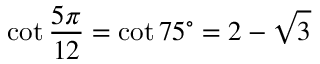Convert formula to latex. <formula><loc_0><loc_0><loc_500><loc_500>\cot { \frac { 5 \pi } { 1 2 } } = \cot 7 5 ^ { \circ } = 2 - { \sqrt { 3 } }</formula> 